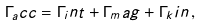Convert formula to latex. <formula><loc_0><loc_0><loc_500><loc_500>\Gamma _ { a } c c = \Gamma _ { i } n t + \Gamma _ { m } a g + \Gamma _ { k } i n \, ,</formula> 